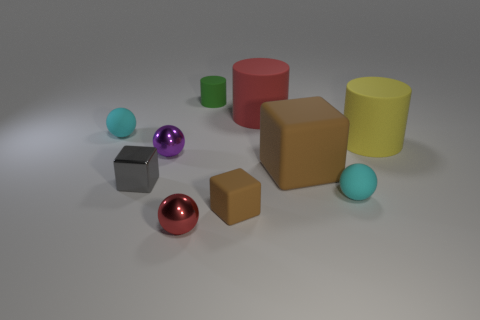Subtract 1 spheres. How many spheres are left? 3 Subtract all purple balls. Subtract all brown blocks. How many balls are left? 3 Subtract all cubes. How many objects are left? 7 Add 8 yellow matte cylinders. How many yellow matte cylinders are left? 9 Add 6 small metal balls. How many small metal balls exist? 8 Subtract 1 gray cubes. How many objects are left? 9 Subtract all small cyan matte objects. Subtract all small green matte things. How many objects are left? 7 